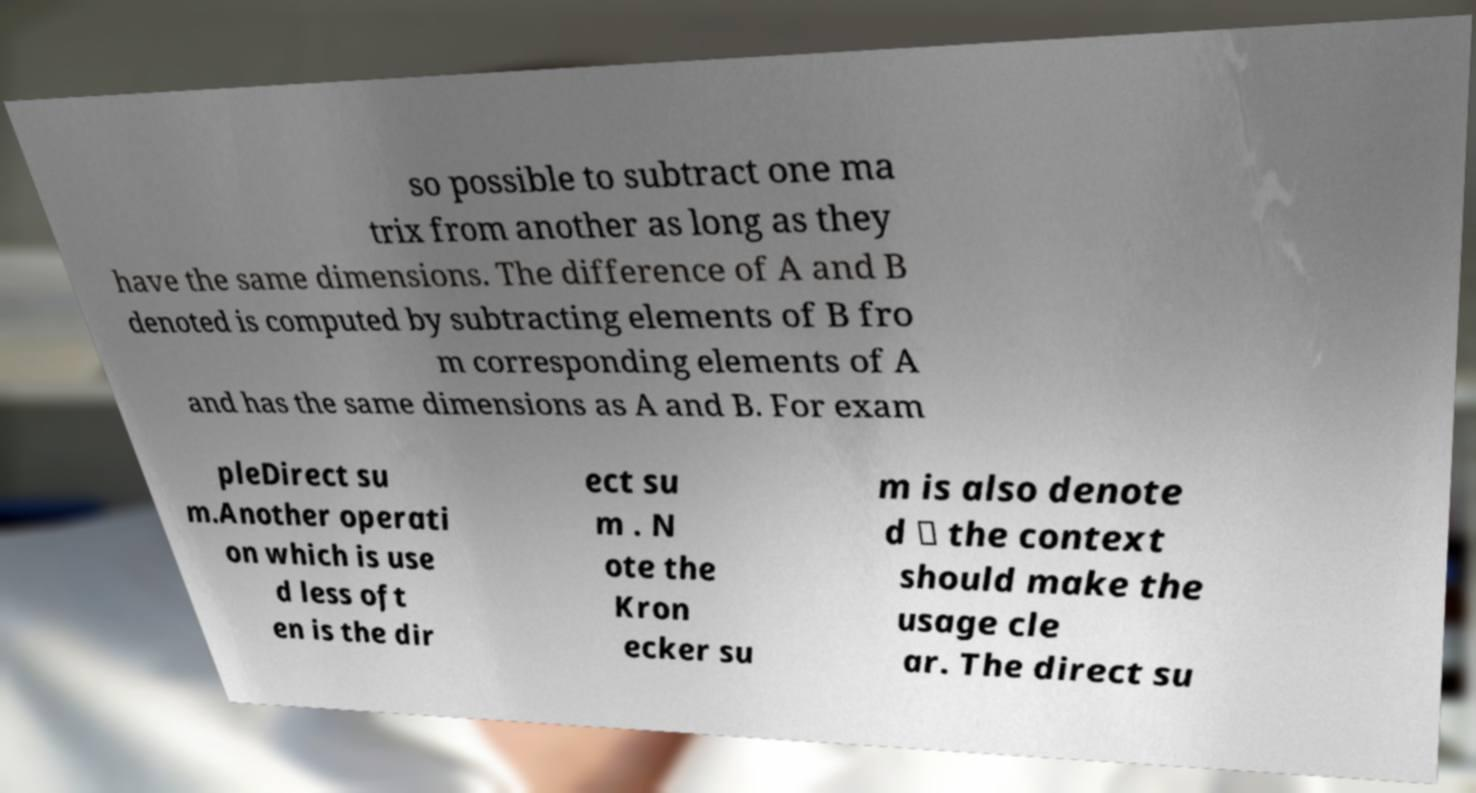Can you accurately transcribe the text from the provided image for me? so possible to subtract one ma trix from another as long as they have the same dimensions. The difference of A and B denoted is computed by subtracting elements of B fro m corresponding elements of A and has the same dimensions as A and B. For exam pleDirect su m.Another operati on which is use d less oft en is the dir ect su m . N ote the Kron ecker su m is also denote d ⊕ the context should make the usage cle ar. The direct su 